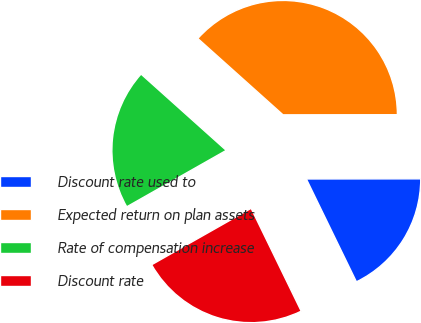<chart> <loc_0><loc_0><loc_500><loc_500><pie_chart><fcel>Discount rate used to<fcel>Expected return on plan assets<fcel>Rate of compensation increase<fcel>Discount rate<nl><fcel>17.81%<fcel>38.36%<fcel>19.84%<fcel>24.0%<nl></chart> 